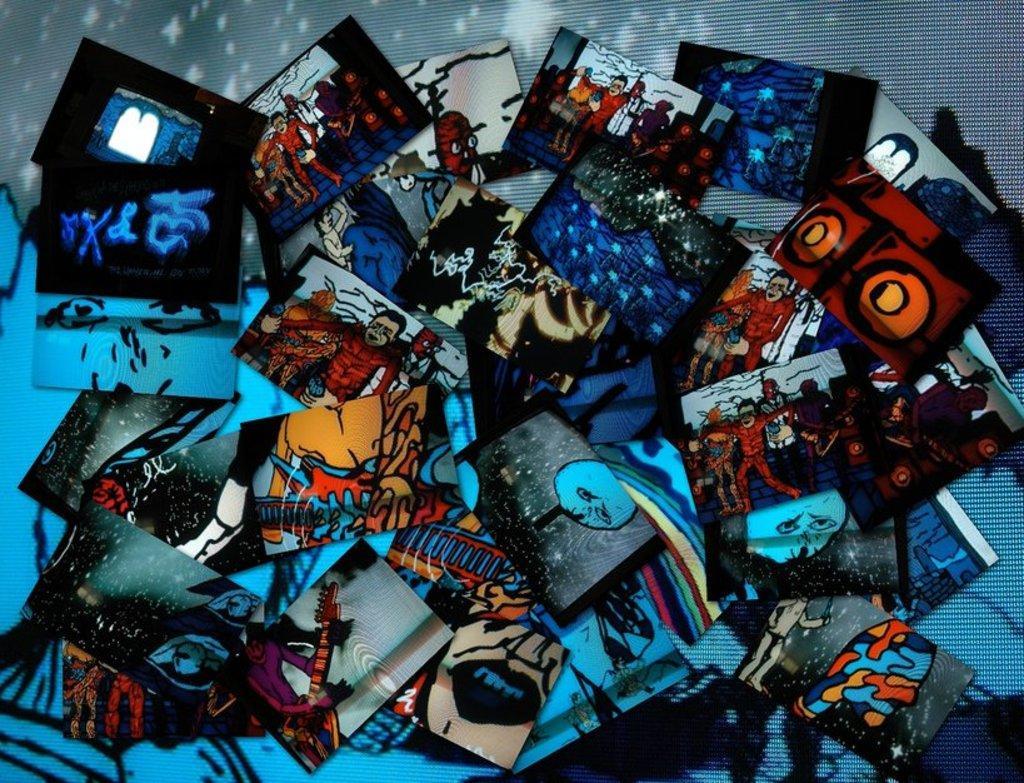Describe this image in one or two sentences. This picture shows few photographs. 